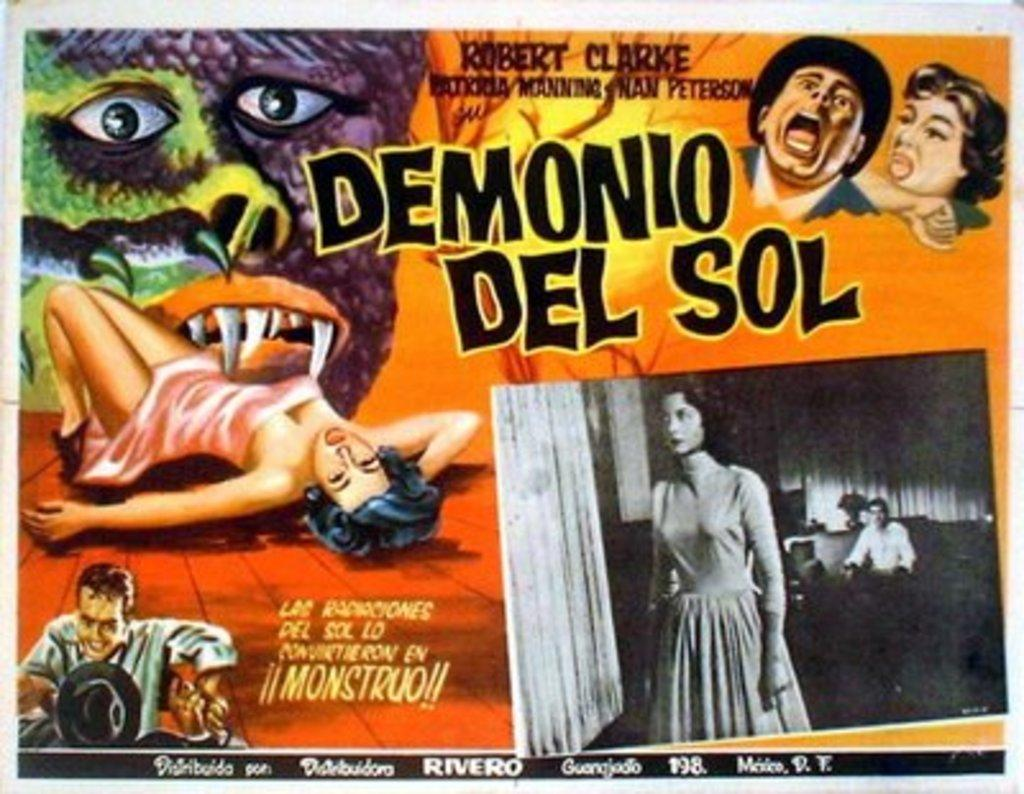<image>
Describe the image concisely. a movie advertisement with a person named Robert in it 